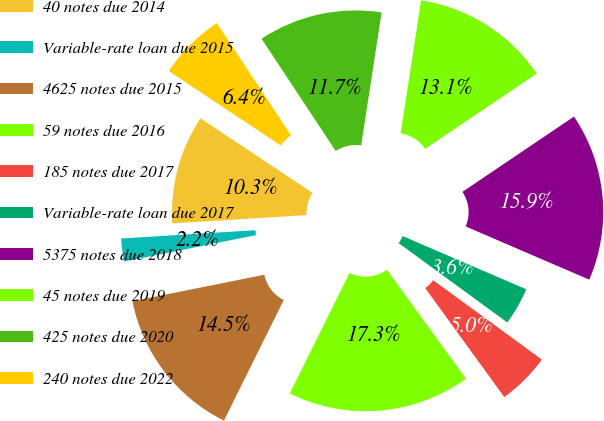Convert chart. <chart><loc_0><loc_0><loc_500><loc_500><pie_chart><fcel>40 notes due 2014<fcel>Variable-rate loan due 2015<fcel>4625 notes due 2015<fcel>59 notes due 2016<fcel>185 notes due 2017<fcel>Variable-rate loan due 2017<fcel>5375 notes due 2018<fcel>45 notes due 2019<fcel>425 notes due 2020<fcel>240 notes due 2022<nl><fcel>10.32%<fcel>2.17%<fcel>14.52%<fcel>17.32%<fcel>4.97%<fcel>3.57%<fcel>15.92%<fcel>13.12%<fcel>11.72%<fcel>6.37%<nl></chart> 